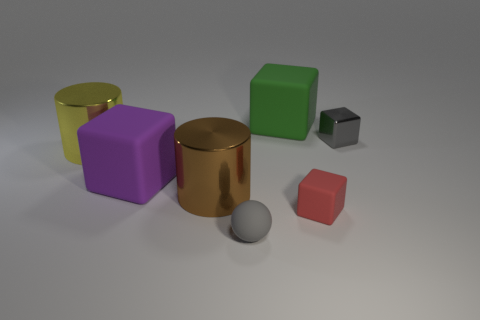Subtract all purple rubber cubes. How many cubes are left? 3 Subtract all brown cylinders. How many cylinders are left? 1 Subtract all red cylinders. How many red blocks are left? 1 Add 6 shiny things. How many shiny things exist? 9 Add 3 yellow shiny cylinders. How many objects exist? 10 Subtract 0 cyan cylinders. How many objects are left? 7 Subtract all balls. How many objects are left? 6 Subtract 2 cubes. How many cubes are left? 2 Subtract all green cylinders. Subtract all brown cubes. How many cylinders are left? 2 Subtract all gray things. Subtract all big purple rubber objects. How many objects are left? 4 